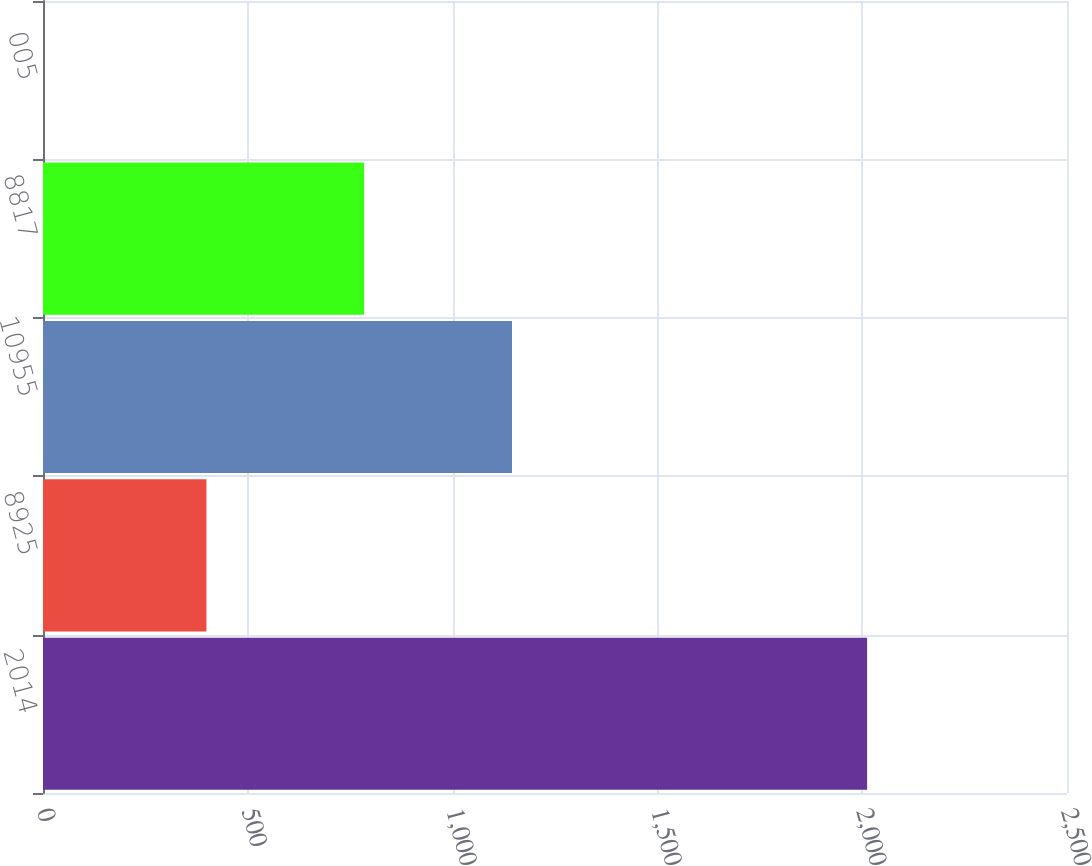<chart> <loc_0><loc_0><loc_500><loc_500><bar_chart><fcel>2014<fcel>8925<fcel>10955<fcel>8817<fcel>005<nl><fcel>2012<fcel>399<fcel>1145<fcel>784<fcel>0.13<nl></chart> 